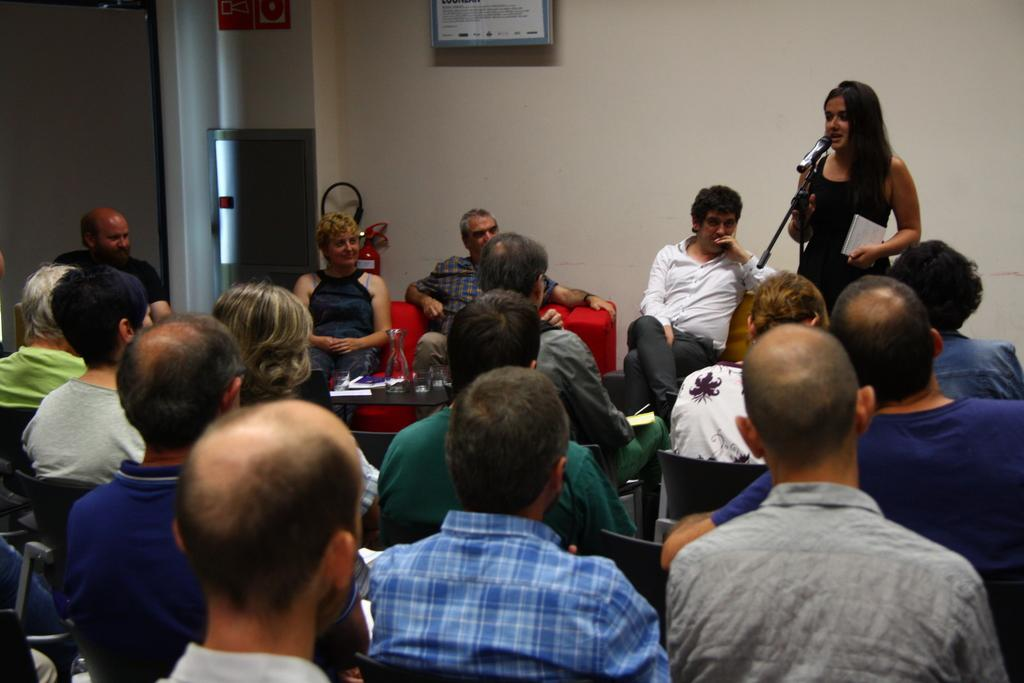How many people are in the image? There is a group of people in the image. What are some of the people doing in the image? Some people are sitting on a chair, and two persons are sitting on a couch. What is the lady in the image doing? A lady is standing and speaking into a microphone. What type of cover is being used to protect the road in the image? There is no mention of a road or cover in the image; it features a group of people with some sitting and one speaking into a microphone. 